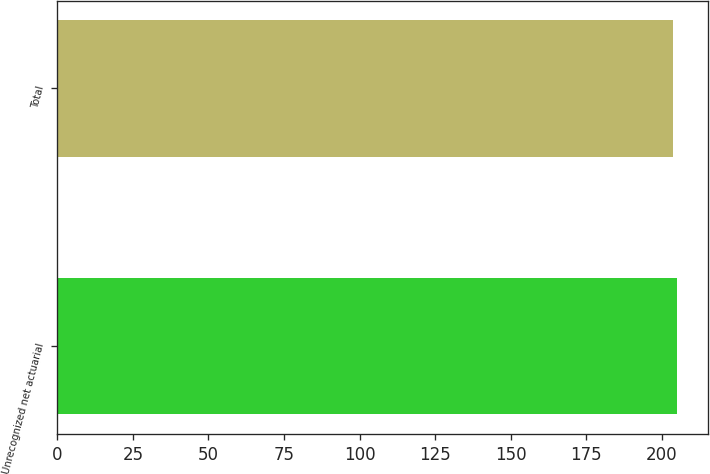Convert chart to OTSL. <chart><loc_0><loc_0><loc_500><loc_500><bar_chart><fcel>Unrecognized net actuarial<fcel>Total<nl><fcel>205<fcel>203.8<nl></chart> 